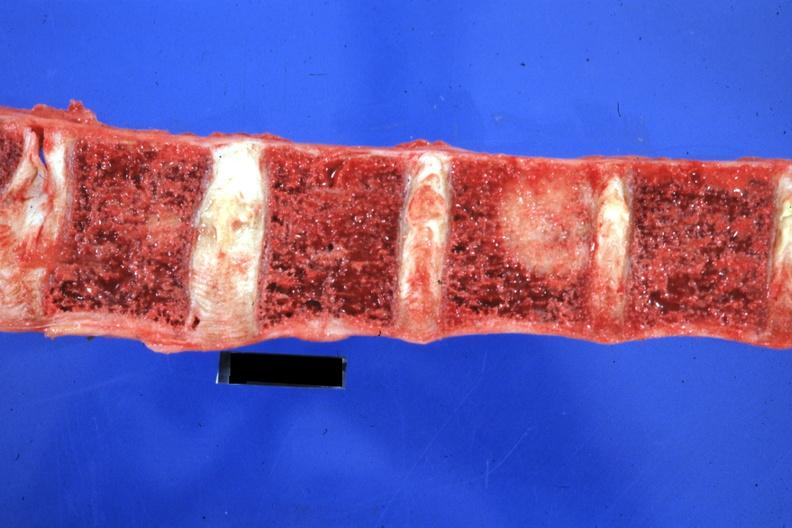what is present?
Answer the question using a single word or phrase. Joints 